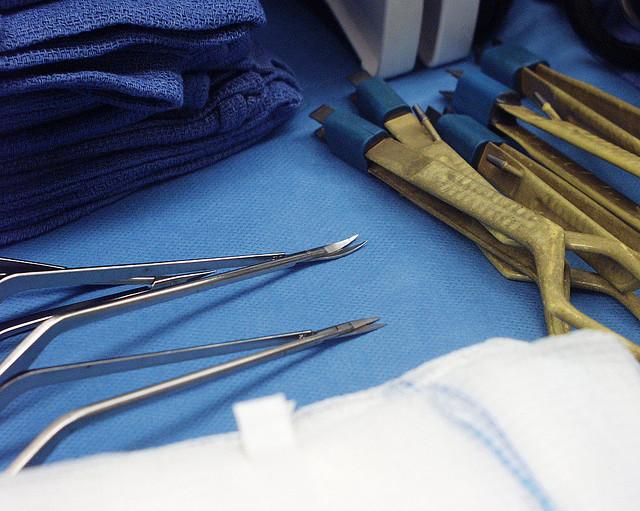What objects are on the table in the picture?
Be succinct. Scissors. Is there a towel on the table?
Answer briefly. Yes. What are the silver objects?
Quick response, please. Scissors. 